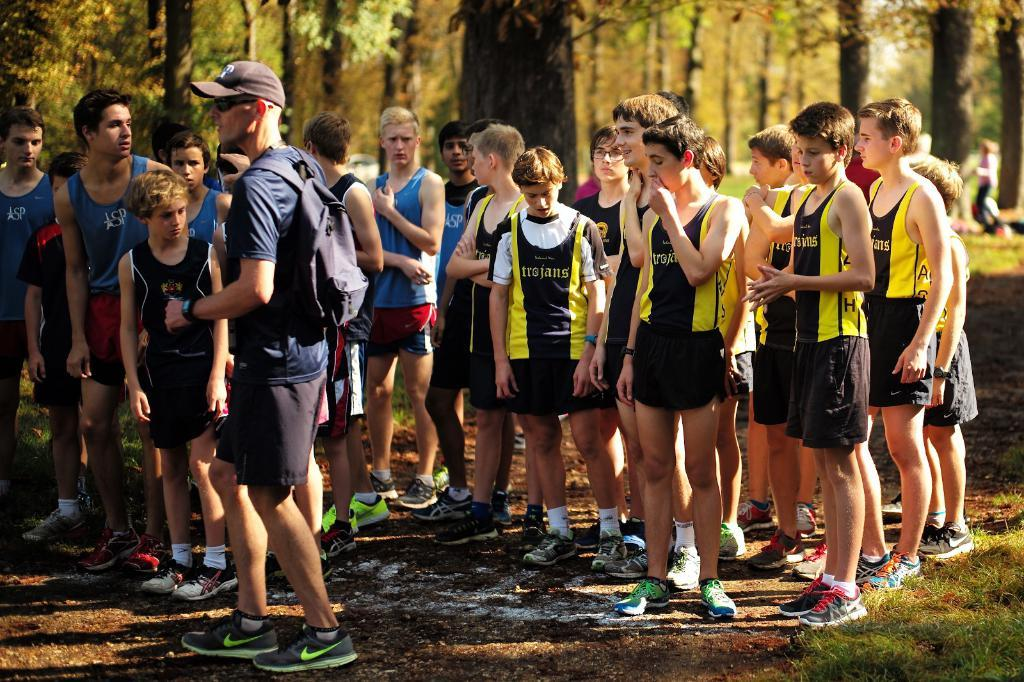What is happening in the image? There are people standing in the image. Can you describe the person on the front? The person on the front is wearing a bag, watch, and cap. What can be seen in the background of the image? There are trees in the background of the image. What type of vegetation is present in the right corner of the image? There are grasses in the right corner of the image. How many quinces are being held by the person on the front? There are no quinces present in the image, so it is not possible to determine how many are being held. 